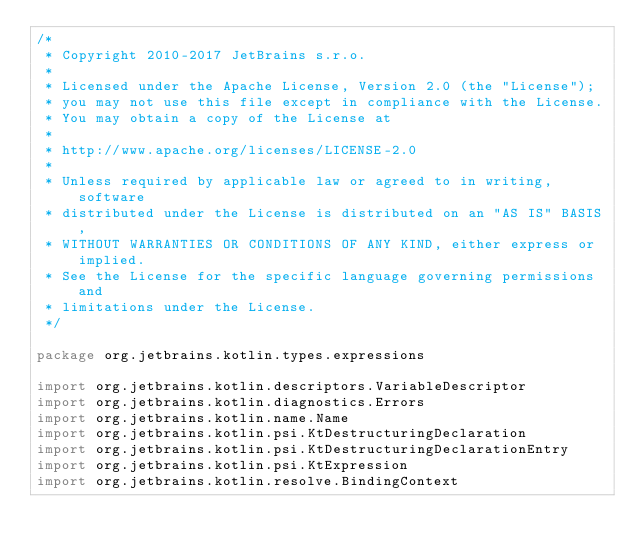Convert code to text. <code><loc_0><loc_0><loc_500><loc_500><_Kotlin_>/*
 * Copyright 2010-2017 JetBrains s.r.o.
 *
 * Licensed under the Apache License, Version 2.0 (the "License");
 * you may not use this file except in compliance with the License.
 * You may obtain a copy of the License at
 *
 * http://www.apache.org/licenses/LICENSE-2.0
 *
 * Unless required by applicable law or agreed to in writing, software
 * distributed under the License is distributed on an "AS IS" BASIS,
 * WITHOUT WARRANTIES OR CONDITIONS OF ANY KIND, either express or implied.
 * See the License for the specific language governing permissions and
 * limitations under the License.
 */

package org.jetbrains.kotlin.types.expressions

import org.jetbrains.kotlin.descriptors.VariableDescriptor
import org.jetbrains.kotlin.diagnostics.Errors
import org.jetbrains.kotlin.name.Name
import org.jetbrains.kotlin.psi.KtDestructuringDeclaration
import org.jetbrains.kotlin.psi.KtDestructuringDeclarationEntry
import org.jetbrains.kotlin.psi.KtExpression
import org.jetbrains.kotlin.resolve.BindingContext</code> 